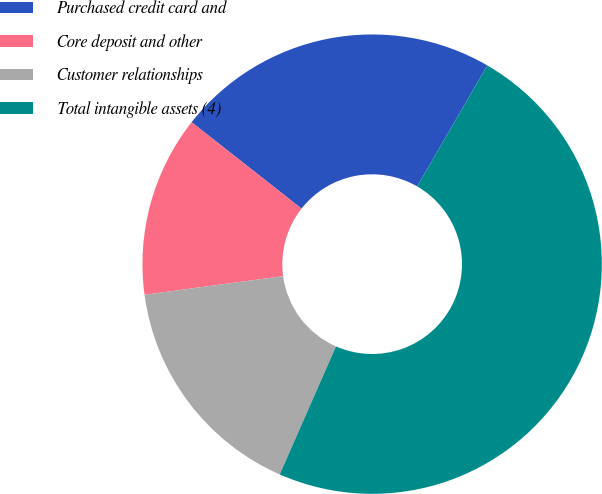Convert chart to OTSL. <chart><loc_0><loc_0><loc_500><loc_500><pie_chart><fcel>Purchased credit card and<fcel>Core deposit and other<fcel>Customer relationships<fcel>Total intangible assets (4)<nl><fcel>22.75%<fcel>12.73%<fcel>16.28%<fcel>48.23%<nl></chart> 